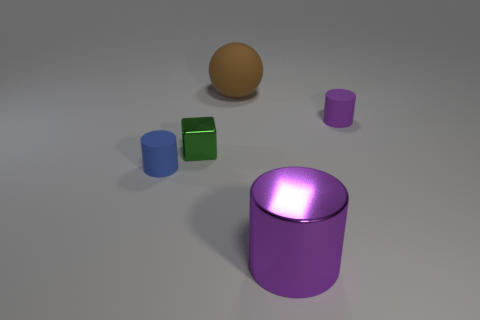Does the tiny blue thing have the same shape as the metal object that is left of the big brown thing?
Provide a succinct answer. No. Are there more large red metal balls than brown matte objects?
Your answer should be very brief. No. Is there any other thing of the same color as the ball?
Ensure brevity in your answer.  No. The big thing that is made of the same material as the small blue thing is what shape?
Your response must be concise. Sphere. The purple object behind the small cylinder left of the large rubber sphere is made of what material?
Ensure brevity in your answer.  Rubber. Does the purple object that is in front of the small purple thing have the same shape as the small purple object?
Offer a very short reply. Yes. Are there more blue cylinders that are behind the small purple matte thing than large purple matte blocks?
Make the answer very short. No. What is the shape of the tiny rubber thing that is the same color as the big metal cylinder?
Provide a succinct answer. Cylinder. How many cylinders are either purple rubber things or tiny objects?
Your answer should be very brief. 2. There is a matte thing that is in front of the tiny object behind the small metal cube; what is its color?
Offer a very short reply. Blue. 